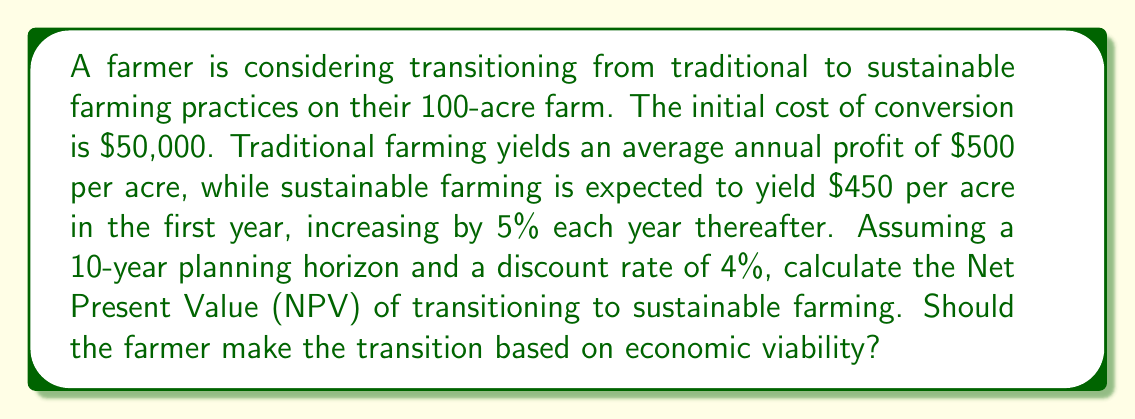Help me with this question. To solve this problem, we need to calculate the NPV of the sustainable farming option and compare it to the NPV of continuing with traditional farming. We'll use the following steps:

1. Calculate the annual cash flows for both options
2. Discount these cash flows to present value
3. Sum the discounted cash flows and subtract the initial investment for the sustainable option
4. Compare the NPVs

Step 1: Annual cash flows

Traditional farming:
Annual profit = $500 × 100 acres = $50,000 (constant for all years)

Sustainable farming:
Year 1: $450 × 100 acres = $45,000
Year 2: $45,000 × 1.05 = $47,250
Year 3: $47,250 × 1.05 = $49,612.50
...and so on

Step 2: Discounting cash flows

We use the present value formula: $PV = \frac{FV}{(1+r)^t}$

where $PV$ is present value, $FV$ is future value, $r$ is the discount rate, and $t$ is the time period.

Step 3: Calculating NPV

For traditional farming:

$$NPV_{traditional} = \sum_{t=1}^{10} \frac{50,000}{(1.04)^t} = 405,518.85$$

For sustainable farming:

$$NPV_{sustainable} = -50,000 + \sum_{t=1}^{10} \frac{45,000 \times 1.05^{t-1}}{(1.04)^t} = 418,345.62$$

Step 4: Comparison

The NPV of sustainable farming ($418,345.62) is higher than the NPV of traditional farming ($405,518.85).
Answer: The NPV of transitioning to sustainable farming is $418,345.62, which is $12,826.77 higher than continuing with traditional farming. Therefore, based on economic viability, the farmer should make the transition to sustainable farming practices. 